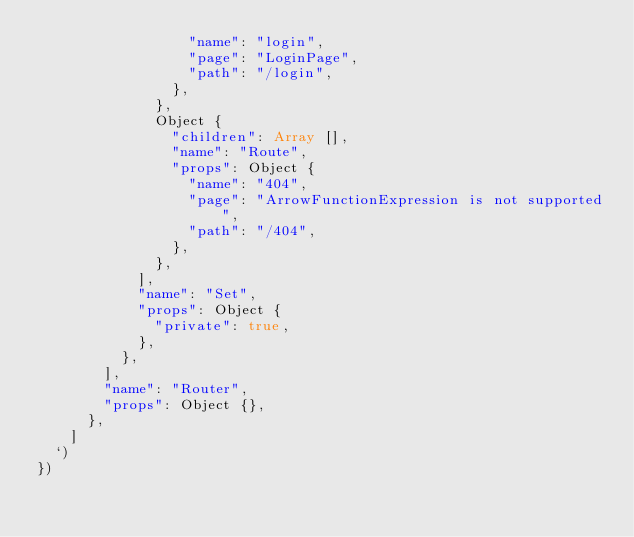Convert code to text. <code><loc_0><loc_0><loc_500><loc_500><_TypeScript_>                  "name": "login",
                  "page": "LoginPage",
                  "path": "/login",
                },
              },
              Object {
                "children": Array [],
                "name": "Route",
                "props": Object {
                  "name": "404",
                  "page": "ArrowFunctionExpression is not supported",
                  "path": "/404",
                },
              },
            ],
            "name": "Set",
            "props": Object {
              "private": true,
            },
          },
        ],
        "name": "Router",
        "props": Object {},
      },
    ]
  `)
})
</code> 